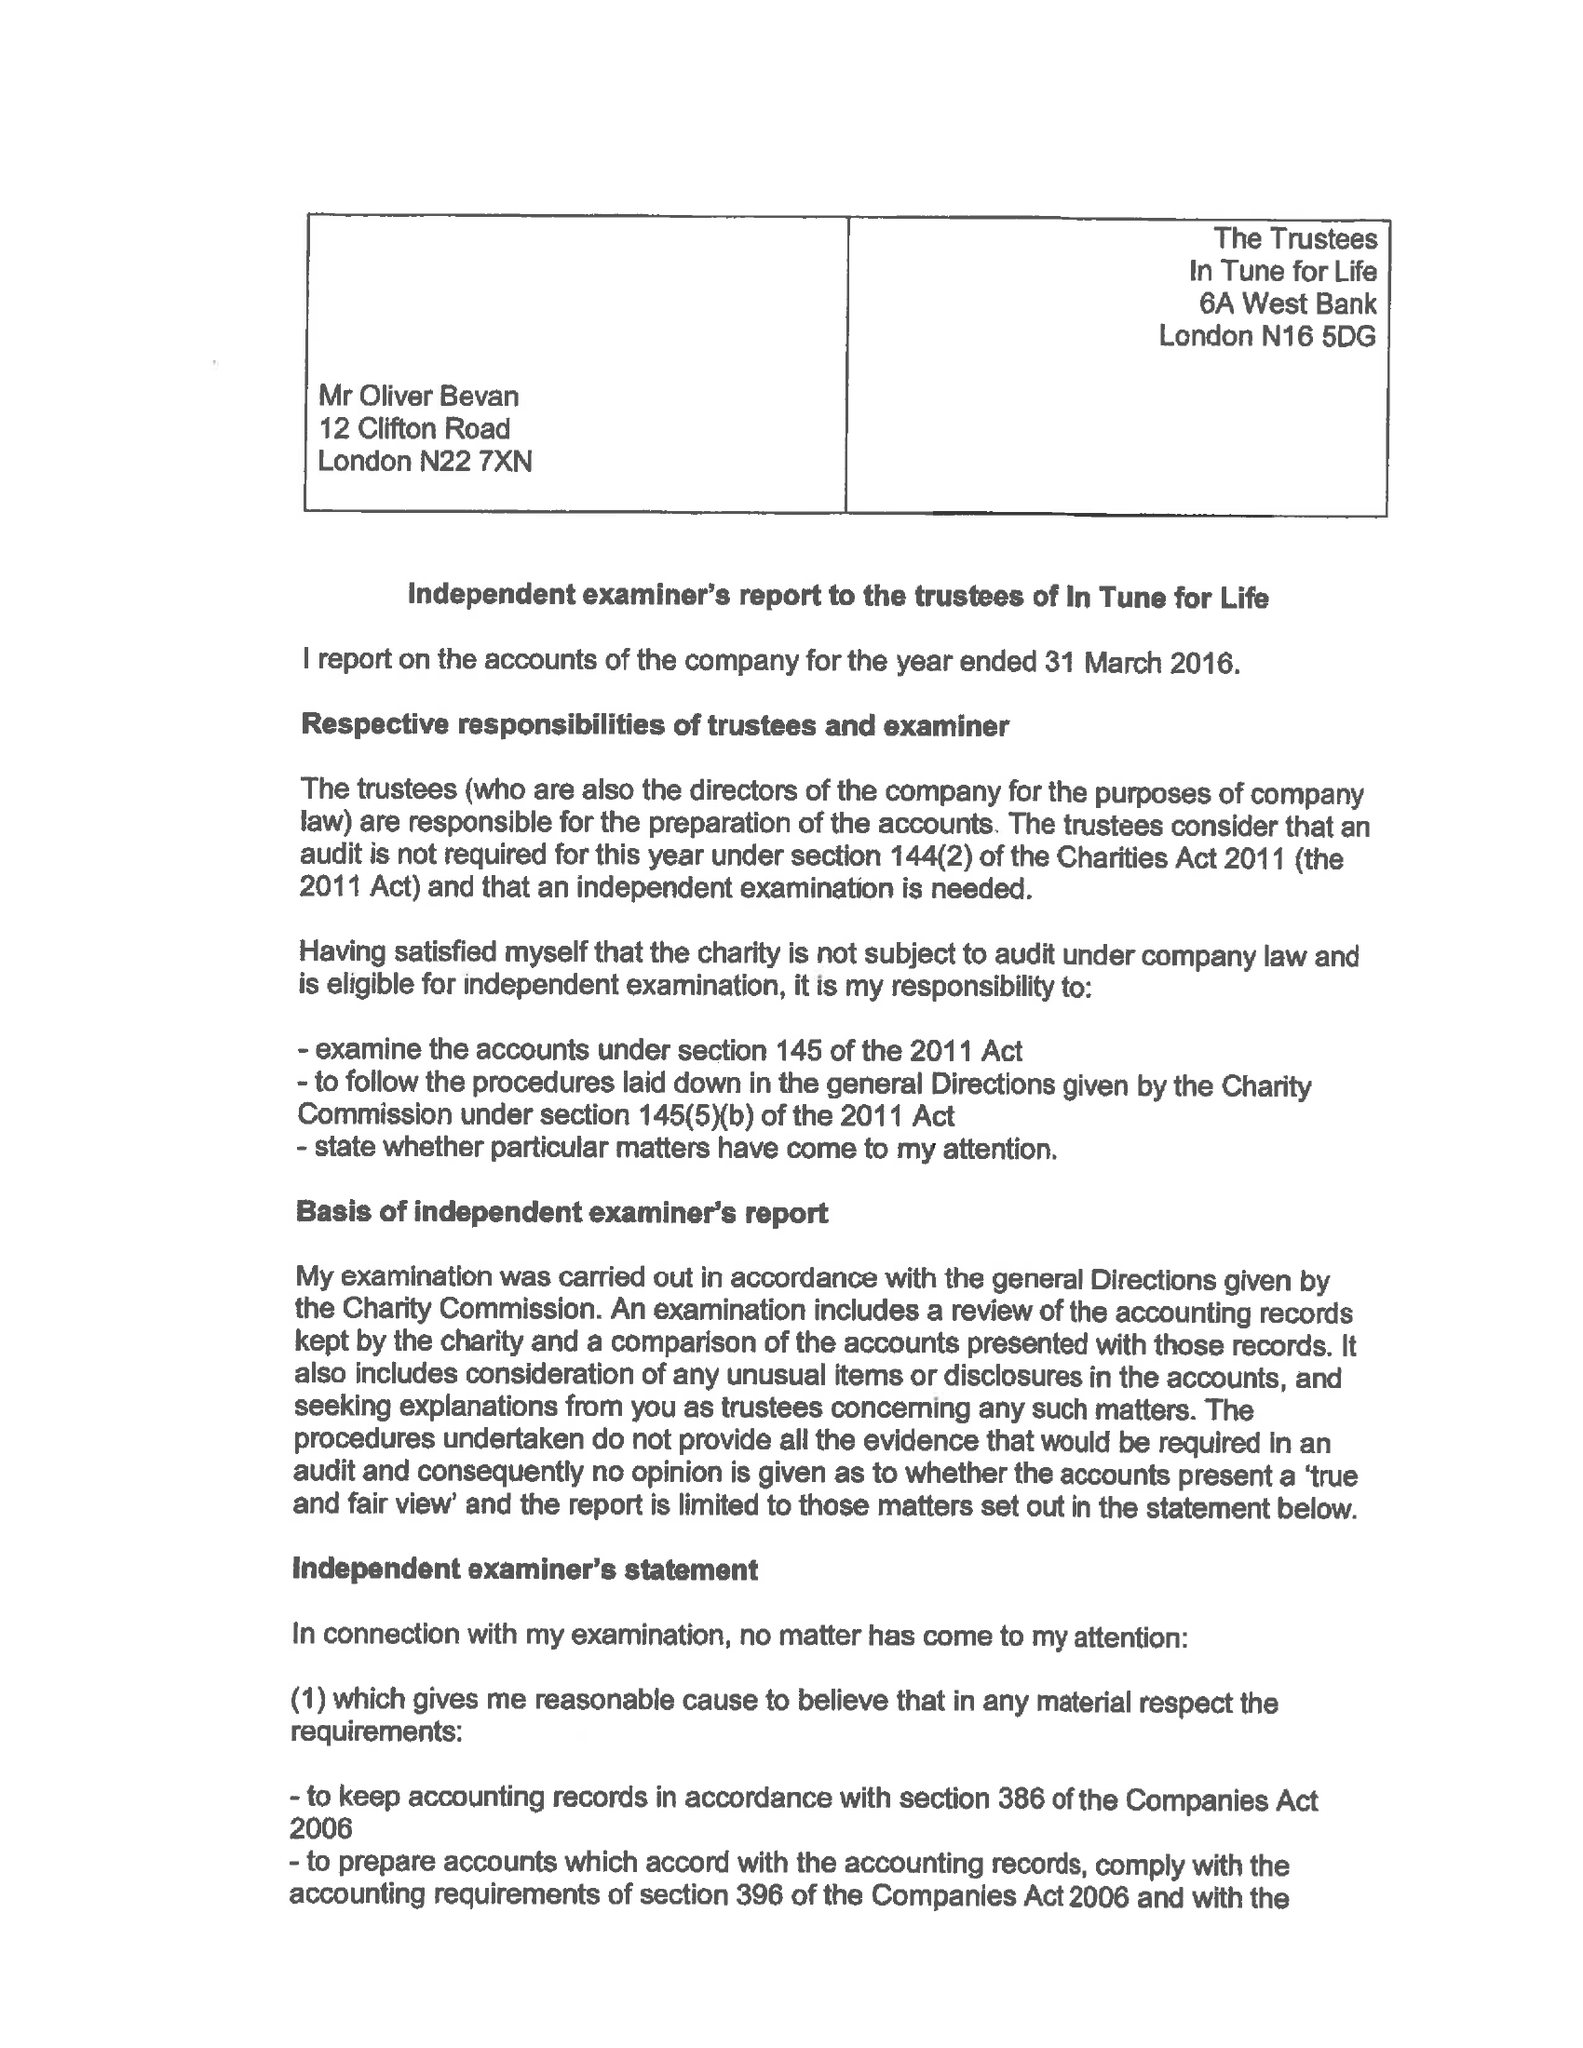What is the value for the address__street_line?
Answer the question using a single word or phrase. 11 GLENEAGLES DRIVE 